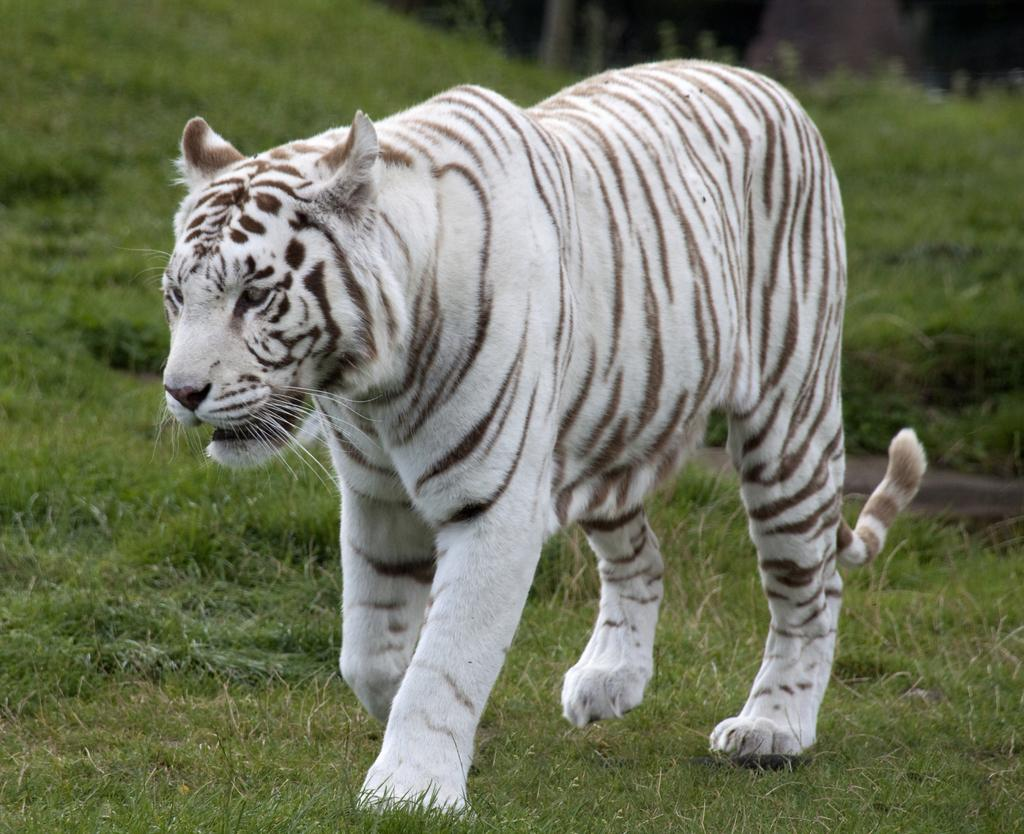What type of animal is in the image? There is a white tiger in the image. What is the background or setting of the image? There is grass visible in the image. What type of jam is being spread on the secretary's desk in the image? There is no jam or secretary present in the image; it features a white tiger and grass. 